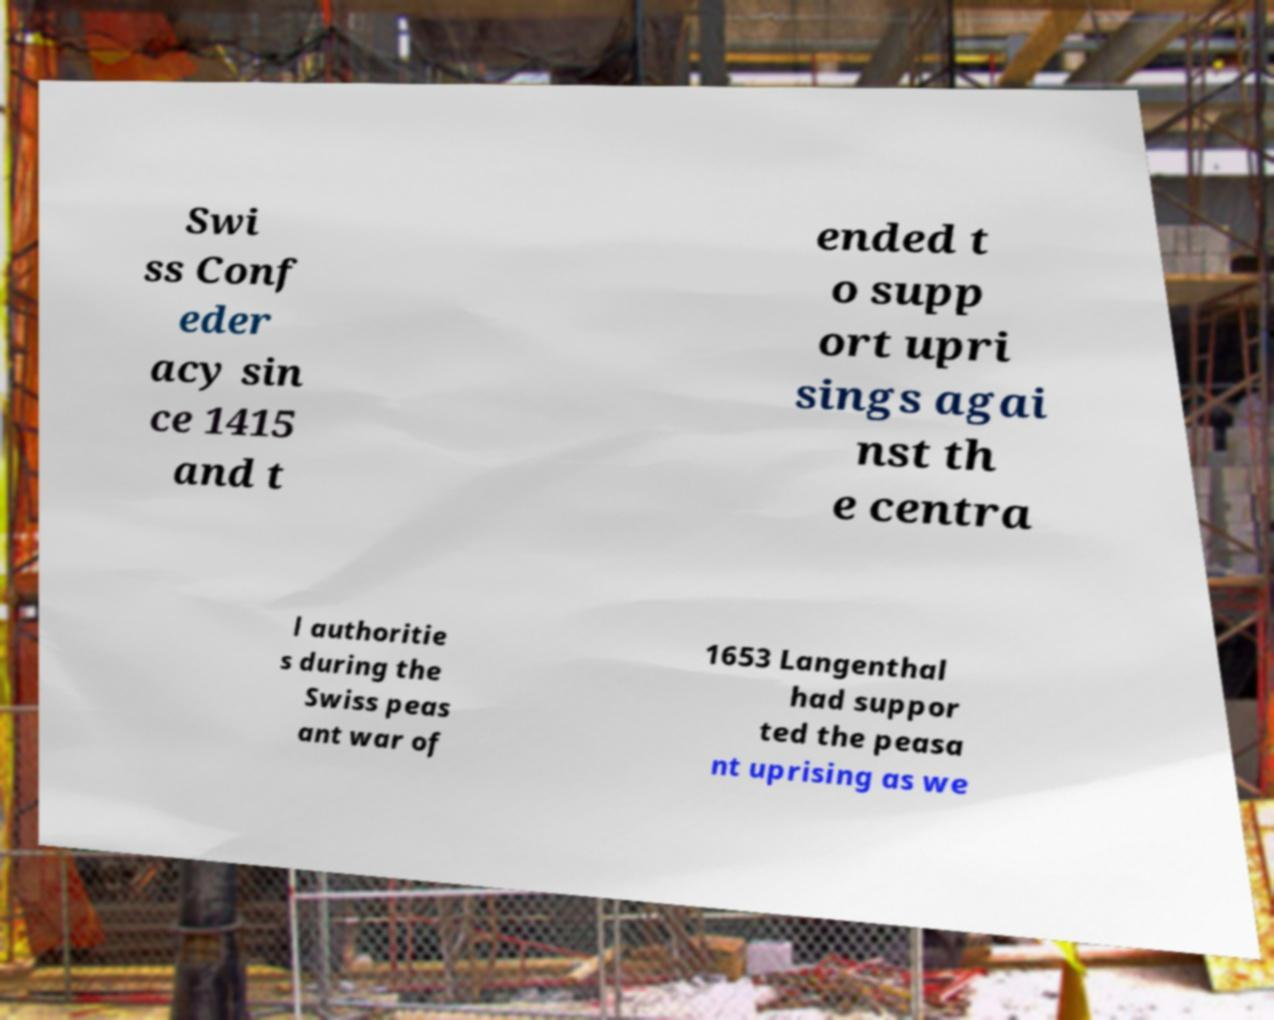Can you read and provide the text displayed in the image?This photo seems to have some interesting text. Can you extract and type it out for me? Swi ss Conf eder acy sin ce 1415 and t ended t o supp ort upri sings agai nst th e centra l authoritie s during the Swiss peas ant war of 1653 Langenthal had suppor ted the peasa nt uprising as we 